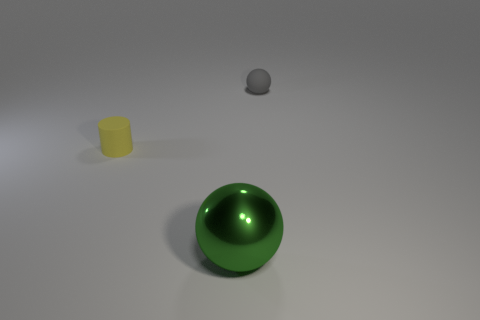Is the number of large things that are to the left of the big metal sphere less than the number of tiny cyan balls?
Make the answer very short. No. There is a rubber object right of the metallic ball; what number of small balls are in front of it?
Offer a very short reply. 0. How big is the object that is both behind the large shiny thing and in front of the gray rubber thing?
Offer a terse response. Small. Is there any other thing that has the same material as the big green sphere?
Your response must be concise. No. Are the yellow cylinder and the tiny thing right of the big metal ball made of the same material?
Give a very brief answer. Yes. Is the number of spheres left of the cylinder less than the number of tiny rubber things on the left side of the green metallic object?
Your answer should be very brief. Yes. What material is the ball that is behind the large metallic sphere?
Your response must be concise. Rubber. There is a object that is both behind the large shiny sphere and in front of the tiny gray ball; what color is it?
Your response must be concise. Yellow. What is the color of the matte object in front of the rubber ball?
Offer a terse response. Yellow. Are there any yellow objects that have the same size as the yellow cylinder?
Offer a terse response. No. 